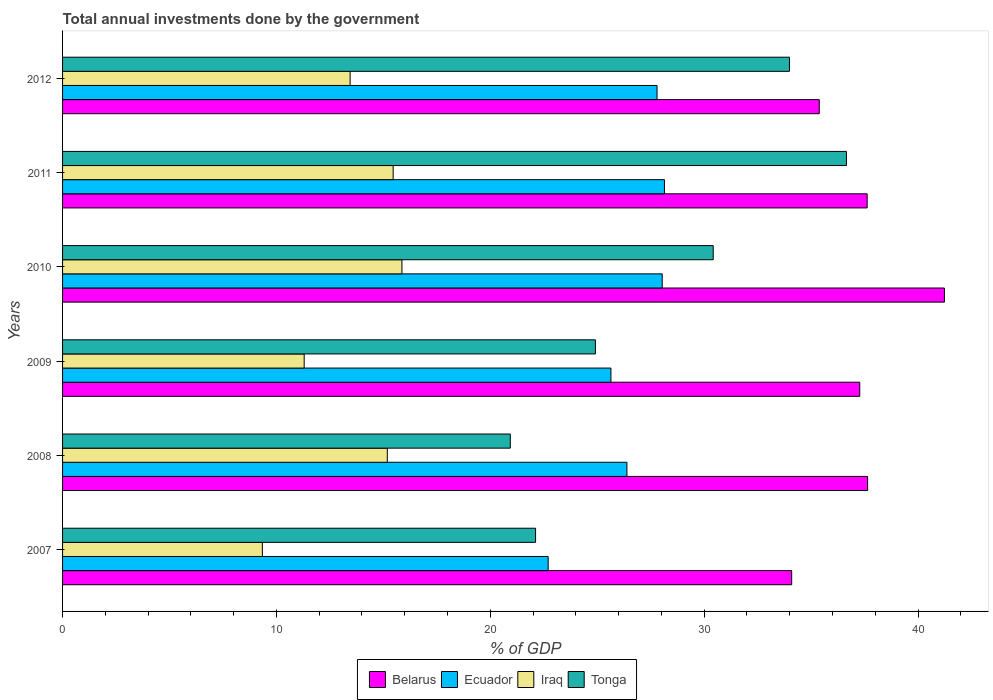How many bars are there on the 5th tick from the bottom?
Offer a very short reply. 4. What is the total annual investments done by the government in Belarus in 2012?
Provide a short and direct response. 35.38. Across all years, what is the maximum total annual investments done by the government in Tonga?
Offer a terse response. 36.65. Across all years, what is the minimum total annual investments done by the government in Ecuador?
Offer a terse response. 22.7. In which year was the total annual investments done by the government in Iraq maximum?
Your response must be concise. 2010. What is the total total annual investments done by the government in Belarus in the graph?
Give a very brief answer. 223.24. What is the difference between the total annual investments done by the government in Belarus in 2008 and that in 2009?
Your answer should be compact. 0.37. What is the difference between the total annual investments done by the government in Iraq in 2010 and the total annual investments done by the government in Ecuador in 2007?
Make the answer very short. -6.84. What is the average total annual investments done by the government in Ecuador per year?
Provide a short and direct response. 26.45. In the year 2008, what is the difference between the total annual investments done by the government in Belarus and total annual investments done by the government in Iraq?
Provide a short and direct response. 22.46. What is the ratio of the total annual investments done by the government in Ecuador in 2009 to that in 2010?
Your answer should be very brief. 0.91. Is the total annual investments done by the government in Ecuador in 2007 less than that in 2010?
Make the answer very short. Yes. What is the difference between the highest and the second highest total annual investments done by the government in Iraq?
Make the answer very short. 0.41. What is the difference between the highest and the lowest total annual investments done by the government in Tonga?
Make the answer very short. 15.72. What does the 2nd bar from the top in 2008 represents?
Make the answer very short. Iraq. What does the 1st bar from the bottom in 2008 represents?
Provide a succinct answer. Belarus. Is it the case that in every year, the sum of the total annual investments done by the government in Ecuador and total annual investments done by the government in Belarus is greater than the total annual investments done by the government in Iraq?
Keep it short and to the point. Yes. How many bars are there?
Ensure brevity in your answer.  24. Are all the bars in the graph horizontal?
Make the answer very short. Yes. How many years are there in the graph?
Provide a short and direct response. 6. Are the values on the major ticks of X-axis written in scientific E-notation?
Your answer should be compact. No. Does the graph contain any zero values?
Offer a very short reply. No. How many legend labels are there?
Offer a very short reply. 4. How are the legend labels stacked?
Ensure brevity in your answer.  Horizontal. What is the title of the graph?
Your answer should be very brief. Total annual investments done by the government. What is the label or title of the X-axis?
Give a very brief answer. % of GDP. What is the % of GDP in Belarus in 2007?
Make the answer very short. 34.09. What is the % of GDP in Ecuador in 2007?
Make the answer very short. 22.7. What is the % of GDP in Iraq in 2007?
Your answer should be very brief. 9.34. What is the % of GDP in Tonga in 2007?
Offer a very short reply. 22.12. What is the % of GDP in Belarus in 2008?
Keep it short and to the point. 37.64. What is the % of GDP of Ecuador in 2008?
Keep it short and to the point. 26.39. What is the % of GDP in Iraq in 2008?
Offer a very short reply. 15.18. What is the % of GDP of Tonga in 2008?
Offer a very short reply. 20.93. What is the % of GDP in Belarus in 2009?
Offer a very short reply. 37.27. What is the % of GDP in Ecuador in 2009?
Your answer should be very brief. 25.64. What is the % of GDP in Iraq in 2009?
Your response must be concise. 11.3. What is the % of GDP of Tonga in 2009?
Offer a very short reply. 24.91. What is the % of GDP in Belarus in 2010?
Your answer should be compact. 41.23. What is the % of GDP in Ecuador in 2010?
Make the answer very short. 28.04. What is the % of GDP of Iraq in 2010?
Your response must be concise. 15.87. What is the % of GDP in Tonga in 2010?
Your answer should be compact. 30.42. What is the % of GDP in Belarus in 2011?
Provide a succinct answer. 37.62. What is the % of GDP of Ecuador in 2011?
Your response must be concise. 28.14. What is the % of GDP in Iraq in 2011?
Offer a terse response. 15.46. What is the % of GDP in Tonga in 2011?
Offer a terse response. 36.65. What is the % of GDP in Belarus in 2012?
Your response must be concise. 35.38. What is the % of GDP in Ecuador in 2012?
Your answer should be very brief. 27.8. What is the % of GDP in Iraq in 2012?
Your answer should be compact. 13.45. What is the % of GDP of Tonga in 2012?
Your answer should be compact. 33.99. Across all years, what is the maximum % of GDP of Belarus?
Provide a short and direct response. 41.23. Across all years, what is the maximum % of GDP of Ecuador?
Offer a very short reply. 28.14. Across all years, what is the maximum % of GDP of Iraq?
Keep it short and to the point. 15.87. Across all years, what is the maximum % of GDP in Tonga?
Provide a short and direct response. 36.65. Across all years, what is the minimum % of GDP of Belarus?
Make the answer very short. 34.09. Across all years, what is the minimum % of GDP of Ecuador?
Your answer should be very brief. 22.7. Across all years, what is the minimum % of GDP in Iraq?
Provide a short and direct response. 9.34. Across all years, what is the minimum % of GDP of Tonga?
Offer a very short reply. 20.93. What is the total % of GDP of Belarus in the graph?
Make the answer very short. 223.24. What is the total % of GDP in Ecuador in the graph?
Your answer should be very brief. 158.71. What is the total % of GDP of Iraq in the graph?
Offer a terse response. 80.59. What is the total % of GDP of Tonga in the graph?
Ensure brevity in your answer.  169.03. What is the difference between the % of GDP in Belarus in 2007 and that in 2008?
Offer a very short reply. -3.55. What is the difference between the % of GDP of Ecuador in 2007 and that in 2008?
Provide a succinct answer. -3.68. What is the difference between the % of GDP in Iraq in 2007 and that in 2008?
Provide a succinct answer. -5.84. What is the difference between the % of GDP in Tonga in 2007 and that in 2008?
Keep it short and to the point. 1.18. What is the difference between the % of GDP in Belarus in 2007 and that in 2009?
Your answer should be compact. -3.18. What is the difference between the % of GDP of Ecuador in 2007 and that in 2009?
Give a very brief answer. -2.93. What is the difference between the % of GDP in Iraq in 2007 and that in 2009?
Provide a short and direct response. -1.95. What is the difference between the % of GDP in Tonga in 2007 and that in 2009?
Your answer should be very brief. -2.8. What is the difference between the % of GDP in Belarus in 2007 and that in 2010?
Keep it short and to the point. -7.14. What is the difference between the % of GDP in Ecuador in 2007 and that in 2010?
Keep it short and to the point. -5.33. What is the difference between the % of GDP in Iraq in 2007 and that in 2010?
Your response must be concise. -6.53. What is the difference between the % of GDP in Tonga in 2007 and that in 2010?
Provide a succinct answer. -8.31. What is the difference between the % of GDP in Belarus in 2007 and that in 2011?
Your answer should be very brief. -3.53. What is the difference between the % of GDP in Ecuador in 2007 and that in 2011?
Make the answer very short. -5.44. What is the difference between the % of GDP of Iraq in 2007 and that in 2011?
Keep it short and to the point. -6.12. What is the difference between the % of GDP in Tonga in 2007 and that in 2011?
Keep it short and to the point. -14.53. What is the difference between the % of GDP of Belarus in 2007 and that in 2012?
Give a very brief answer. -1.29. What is the difference between the % of GDP of Ecuador in 2007 and that in 2012?
Give a very brief answer. -5.09. What is the difference between the % of GDP of Iraq in 2007 and that in 2012?
Offer a terse response. -4.1. What is the difference between the % of GDP of Tonga in 2007 and that in 2012?
Offer a terse response. -11.87. What is the difference between the % of GDP in Belarus in 2008 and that in 2009?
Provide a succinct answer. 0.37. What is the difference between the % of GDP in Ecuador in 2008 and that in 2009?
Your answer should be very brief. 0.75. What is the difference between the % of GDP in Iraq in 2008 and that in 2009?
Provide a succinct answer. 3.89. What is the difference between the % of GDP of Tonga in 2008 and that in 2009?
Keep it short and to the point. -3.98. What is the difference between the % of GDP of Belarus in 2008 and that in 2010?
Your answer should be very brief. -3.59. What is the difference between the % of GDP in Ecuador in 2008 and that in 2010?
Ensure brevity in your answer.  -1.65. What is the difference between the % of GDP in Iraq in 2008 and that in 2010?
Your response must be concise. -0.68. What is the difference between the % of GDP of Tonga in 2008 and that in 2010?
Your response must be concise. -9.49. What is the difference between the % of GDP of Belarus in 2008 and that in 2011?
Keep it short and to the point. 0.02. What is the difference between the % of GDP in Ecuador in 2008 and that in 2011?
Offer a very short reply. -1.75. What is the difference between the % of GDP in Iraq in 2008 and that in 2011?
Your answer should be very brief. -0.27. What is the difference between the % of GDP of Tonga in 2008 and that in 2011?
Your answer should be compact. -15.72. What is the difference between the % of GDP in Belarus in 2008 and that in 2012?
Keep it short and to the point. 2.26. What is the difference between the % of GDP of Ecuador in 2008 and that in 2012?
Your answer should be compact. -1.41. What is the difference between the % of GDP in Iraq in 2008 and that in 2012?
Offer a terse response. 1.74. What is the difference between the % of GDP of Tonga in 2008 and that in 2012?
Provide a succinct answer. -13.05. What is the difference between the % of GDP of Belarus in 2009 and that in 2010?
Your answer should be very brief. -3.96. What is the difference between the % of GDP of Ecuador in 2009 and that in 2010?
Your response must be concise. -2.4. What is the difference between the % of GDP in Iraq in 2009 and that in 2010?
Your answer should be compact. -4.57. What is the difference between the % of GDP of Tonga in 2009 and that in 2010?
Offer a very short reply. -5.51. What is the difference between the % of GDP of Belarus in 2009 and that in 2011?
Keep it short and to the point. -0.35. What is the difference between the % of GDP of Ecuador in 2009 and that in 2011?
Provide a short and direct response. -2.5. What is the difference between the % of GDP of Iraq in 2009 and that in 2011?
Provide a short and direct response. -4.16. What is the difference between the % of GDP in Tonga in 2009 and that in 2011?
Offer a very short reply. -11.74. What is the difference between the % of GDP in Belarus in 2009 and that in 2012?
Provide a short and direct response. 1.89. What is the difference between the % of GDP in Ecuador in 2009 and that in 2012?
Offer a very short reply. -2.16. What is the difference between the % of GDP of Iraq in 2009 and that in 2012?
Your response must be concise. -2.15. What is the difference between the % of GDP of Tonga in 2009 and that in 2012?
Provide a short and direct response. -9.07. What is the difference between the % of GDP of Belarus in 2010 and that in 2011?
Make the answer very short. 3.61. What is the difference between the % of GDP in Ecuador in 2010 and that in 2011?
Your response must be concise. -0.11. What is the difference between the % of GDP in Iraq in 2010 and that in 2011?
Offer a terse response. 0.41. What is the difference between the % of GDP in Tonga in 2010 and that in 2011?
Keep it short and to the point. -6.23. What is the difference between the % of GDP of Belarus in 2010 and that in 2012?
Offer a very short reply. 5.85. What is the difference between the % of GDP of Ecuador in 2010 and that in 2012?
Provide a succinct answer. 0.24. What is the difference between the % of GDP in Iraq in 2010 and that in 2012?
Offer a very short reply. 2.42. What is the difference between the % of GDP in Tonga in 2010 and that in 2012?
Offer a very short reply. -3.56. What is the difference between the % of GDP in Belarus in 2011 and that in 2012?
Offer a terse response. 2.24. What is the difference between the % of GDP of Ecuador in 2011 and that in 2012?
Keep it short and to the point. 0.35. What is the difference between the % of GDP in Iraq in 2011 and that in 2012?
Give a very brief answer. 2.01. What is the difference between the % of GDP of Tonga in 2011 and that in 2012?
Offer a terse response. 2.66. What is the difference between the % of GDP in Belarus in 2007 and the % of GDP in Ecuador in 2008?
Ensure brevity in your answer.  7.7. What is the difference between the % of GDP of Belarus in 2007 and the % of GDP of Iraq in 2008?
Your answer should be compact. 18.91. What is the difference between the % of GDP in Belarus in 2007 and the % of GDP in Tonga in 2008?
Offer a terse response. 13.16. What is the difference between the % of GDP of Ecuador in 2007 and the % of GDP of Iraq in 2008?
Provide a succinct answer. 7.52. What is the difference between the % of GDP of Ecuador in 2007 and the % of GDP of Tonga in 2008?
Keep it short and to the point. 1.77. What is the difference between the % of GDP of Iraq in 2007 and the % of GDP of Tonga in 2008?
Provide a succinct answer. -11.59. What is the difference between the % of GDP of Belarus in 2007 and the % of GDP of Ecuador in 2009?
Your response must be concise. 8.45. What is the difference between the % of GDP in Belarus in 2007 and the % of GDP in Iraq in 2009?
Give a very brief answer. 22.8. What is the difference between the % of GDP in Belarus in 2007 and the % of GDP in Tonga in 2009?
Ensure brevity in your answer.  9.18. What is the difference between the % of GDP of Ecuador in 2007 and the % of GDP of Iraq in 2009?
Your answer should be very brief. 11.41. What is the difference between the % of GDP of Ecuador in 2007 and the % of GDP of Tonga in 2009?
Ensure brevity in your answer.  -2.21. What is the difference between the % of GDP in Iraq in 2007 and the % of GDP in Tonga in 2009?
Your response must be concise. -15.57. What is the difference between the % of GDP in Belarus in 2007 and the % of GDP in Ecuador in 2010?
Keep it short and to the point. 6.05. What is the difference between the % of GDP of Belarus in 2007 and the % of GDP of Iraq in 2010?
Your response must be concise. 18.22. What is the difference between the % of GDP of Belarus in 2007 and the % of GDP of Tonga in 2010?
Ensure brevity in your answer.  3.67. What is the difference between the % of GDP in Ecuador in 2007 and the % of GDP in Iraq in 2010?
Provide a short and direct response. 6.84. What is the difference between the % of GDP of Ecuador in 2007 and the % of GDP of Tonga in 2010?
Provide a succinct answer. -7.72. What is the difference between the % of GDP in Iraq in 2007 and the % of GDP in Tonga in 2010?
Your response must be concise. -21.08. What is the difference between the % of GDP in Belarus in 2007 and the % of GDP in Ecuador in 2011?
Make the answer very short. 5.95. What is the difference between the % of GDP of Belarus in 2007 and the % of GDP of Iraq in 2011?
Make the answer very short. 18.63. What is the difference between the % of GDP of Belarus in 2007 and the % of GDP of Tonga in 2011?
Your answer should be compact. -2.56. What is the difference between the % of GDP in Ecuador in 2007 and the % of GDP in Iraq in 2011?
Your response must be concise. 7.25. What is the difference between the % of GDP in Ecuador in 2007 and the % of GDP in Tonga in 2011?
Make the answer very short. -13.95. What is the difference between the % of GDP of Iraq in 2007 and the % of GDP of Tonga in 2011?
Offer a very short reply. -27.31. What is the difference between the % of GDP of Belarus in 2007 and the % of GDP of Ecuador in 2012?
Your answer should be compact. 6.3. What is the difference between the % of GDP in Belarus in 2007 and the % of GDP in Iraq in 2012?
Your answer should be compact. 20.65. What is the difference between the % of GDP of Belarus in 2007 and the % of GDP of Tonga in 2012?
Offer a terse response. 0.1. What is the difference between the % of GDP of Ecuador in 2007 and the % of GDP of Iraq in 2012?
Your response must be concise. 9.26. What is the difference between the % of GDP in Ecuador in 2007 and the % of GDP in Tonga in 2012?
Your answer should be compact. -11.28. What is the difference between the % of GDP of Iraq in 2007 and the % of GDP of Tonga in 2012?
Offer a terse response. -24.65. What is the difference between the % of GDP of Belarus in 2008 and the % of GDP of Ecuador in 2009?
Provide a short and direct response. 12. What is the difference between the % of GDP of Belarus in 2008 and the % of GDP of Iraq in 2009?
Your answer should be compact. 26.34. What is the difference between the % of GDP in Belarus in 2008 and the % of GDP in Tonga in 2009?
Give a very brief answer. 12.73. What is the difference between the % of GDP of Ecuador in 2008 and the % of GDP of Iraq in 2009?
Provide a short and direct response. 15.09. What is the difference between the % of GDP of Ecuador in 2008 and the % of GDP of Tonga in 2009?
Offer a terse response. 1.47. What is the difference between the % of GDP in Iraq in 2008 and the % of GDP in Tonga in 2009?
Your answer should be compact. -9.73. What is the difference between the % of GDP in Belarus in 2008 and the % of GDP in Ecuador in 2010?
Offer a terse response. 9.6. What is the difference between the % of GDP of Belarus in 2008 and the % of GDP of Iraq in 2010?
Offer a very short reply. 21.77. What is the difference between the % of GDP of Belarus in 2008 and the % of GDP of Tonga in 2010?
Ensure brevity in your answer.  7.22. What is the difference between the % of GDP of Ecuador in 2008 and the % of GDP of Iraq in 2010?
Your response must be concise. 10.52. What is the difference between the % of GDP in Ecuador in 2008 and the % of GDP in Tonga in 2010?
Offer a terse response. -4.04. What is the difference between the % of GDP in Iraq in 2008 and the % of GDP in Tonga in 2010?
Your answer should be compact. -15.24. What is the difference between the % of GDP in Belarus in 2008 and the % of GDP in Ecuador in 2011?
Offer a terse response. 9.5. What is the difference between the % of GDP of Belarus in 2008 and the % of GDP of Iraq in 2011?
Keep it short and to the point. 22.18. What is the difference between the % of GDP in Ecuador in 2008 and the % of GDP in Iraq in 2011?
Your answer should be very brief. 10.93. What is the difference between the % of GDP in Ecuador in 2008 and the % of GDP in Tonga in 2011?
Give a very brief answer. -10.26. What is the difference between the % of GDP in Iraq in 2008 and the % of GDP in Tonga in 2011?
Ensure brevity in your answer.  -21.47. What is the difference between the % of GDP in Belarus in 2008 and the % of GDP in Ecuador in 2012?
Your answer should be very brief. 9.85. What is the difference between the % of GDP of Belarus in 2008 and the % of GDP of Iraq in 2012?
Keep it short and to the point. 24.2. What is the difference between the % of GDP of Belarus in 2008 and the % of GDP of Tonga in 2012?
Make the answer very short. 3.65. What is the difference between the % of GDP of Ecuador in 2008 and the % of GDP of Iraq in 2012?
Give a very brief answer. 12.94. What is the difference between the % of GDP of Ecuador in 2008 and the % of GDP of Tonga in 2012?
Your answer should be very brief. -7.6. What is the difference between the % of GDP of Iraq in 2008 and the % of GDP of Tonga in 2012?
Provide a succinct answer. -18.8. What is the difference between the % of GDP in Belarus in 2009 and the % of GDP in Ecuador in 2010?
Offer a very short reply. 9.24. What is the difference between the % of GDP in Belarus in 2009 and the % of GDP in Iraq in 2010?
Provide a succinct answer. 21.41. What is the difference between the % of GDP in Belarus in 2009 and the % of GDP in Tonga in 2010?
Ensure brevity in your answer.  6.85. What is the difference between the % of GDP in Ecuador in 2009 and the % of GDP in Iraq in 2010?
Your answer should be compact. 9.77. What is the difference between the % of GDP of Ecuador in 2009 and the % of GDP of Tonga in 2010?
Give a very brief answer. -4.78. What is the difference between the % of GDP of Iraq in 2009 and the % of GDP of Tonga in 2010?
Give a very brief answer. -19.13. What is the difference between the % of GDP of Belarus in 2009 and the % of GDP of Ecuador in 2011?
Your answer should be very brief. 9.13. What is the difference between the % of GDP of Belarus in 2009 and the % of GDP of Iraq in 2011?
Your answer should be compact. 21.82. What is the difference between the % of GDP of Belarus in 2009 and the % of GDP of Tonga in 2011?
Ensure brevity in your answer.  0.62. What is the difference between the % of GDP in Ecuador in 2009 and the % of GDP in Iraq in 2011?
Provide a short and direct response. 10.18. What is the difference between the % of GDP of Ecuador in 2009 and the % of GDP of Tonga in 2011?
Your answer should be compact. -11.01. What is the difference between the % of GDP of Iraq in 2009 and the % of GDP of Tonga in 2011?
Keep it short and to the point. -25.36. What is the difference between the % of GDP in Belarus in 2009 and the % of GDP in Ecuador in 2012?
Offer a terse response. 9.48. What is the difference between the % of GDP of Belarus in 2009 and the % of GDP of Iraq in 2012?
Offer a very short reply. 23.83. What is the difference between the % of GDP of Belarus in 2009 and the % of GDP of Tonga in 2012?
Your answer should be very brief. 3.29. What is the difference between the % of GDP of Ecuador in 2009 and the % of GDP of Iraq in 2012?
Your response must be concise. 12.19. What is the difference between the % of GDP of Ecuador in 2009 and the % of GDP of Tonga in 2012?
Give a very brief answer. -8.35. What is the difference between the % of GDP in Iraq in 2009 and the % of GDP in Tonga in 2012?
Your response must be concise. -22.69. What is the difference between the % of GDP in Belarus in 2010 and the % of GDP in Ecuador in 2011?
Your answer should be very brief. 13.09. What is the difference between the % of GDP in Belarus in 2010 and the % of GDP in Iraq in 2011?
Offer a very short reply. 25.77. What is the difference between the % of GDP in Belarus in 2010 and the % of GDP in Tonga in 2011?
Offer a very short reply. 4.58. What is the difference between the % of GDP in Ecuador in 2010 and the % of GDP in Iraq in 2011?
Make the answer very short. 12.58. What is the difference between the % of GDP of Ecuador in 2010 and the % of GDP of Tonga in 2011?
Offer a very short reply. -8.61. What is the difference between the % of GDP of Iraq in 2010 and the % of GDP of Tonga in 2011?
Keep it short and to the point. -20.78. What is the difference between the % of GDP in Belarus in 2010 and the % of GDP in Ecuador in 2012?
Your response must be concise. 13.44. What is the difference between the % of GDP of Belarus in 2010 and the % of GDP of Iraq in 2012?
Provide a short and direct response. 27.79. What is the difference between the % of GDP in Belarus in 2010 and the % of GDP in Tonga in 2012?
Offer a very short reply. 7.24. What is the difference between the % of GDP in Ecuador in 2010 and the % of GDP in Iraq in 2012?
Give a very brief answer. 14.59. What is the difference between the % of GDP in Ecuador in 2010 and the % of GDP in Tonga in 2012?
Provide a short and direct response. -5.95. What is the difference between the % of GDP in Iraq in 2010 and the % of GDP in Tonga in 2012?
Offer a terse response. -18.12. What is the difference between the % of GDP in Belarus in 2011 and the % of GDP in Ecuador in 2012?
Offer a terse response. 9.82. What is the difference between the % of GDP in Belarus in 2011 and the % of GDP in Iraq in 2012?
Ensure brevity in your answer.  24.17. What is the difference between the % of GDP of Belarus in 2011 and the % of GDP of Tonga in 2012?
Offer a very short reply. 3.63. What is the difference between the % of GDP of Ecuador in 2011 and the % of GDP of Iraq in 2012?
Provide a short and direct response. 14.7. What is the difference between the % of GDP in Ecuador in 2011 and the % of GDP in Tonga in 2012?
Provide a short and direct response. -5.85. What is the difference between the % of GDP in Iraq in 2011 and the % of GDP in Tonga in 2012?
Make the answer very short. -18.53. What is the average % of GDP of Belarus per year?
Give a very brief answer. 37.21. What is the average % of GDP in Ecuador per year?
Provide a short and direct response. 26.45. What is the average % of GDP in Iraq per year?
Provide a short and direct response. 13.43. What is the average % of GDP in Tonga per year?
Provide a short and direct response. 28.17. In the year 2007, what is the difference between the % of GDP of Belarus and % of GDP of Ecuador?
Make the answer very short. 11.39. In the year 2007, what is the difference between the % of GDP in Belarus and % of GDP in Iraq?
Ensure brevity in your answer.  24.75. In the year 2007, what is the difference between the % of GDP in Belarus and % of GDP in Tonga?
Provide a short and direct response. 11.97. In the year 2007, what is the difference between the % of GDP in Ecuador and % of GDP in Iraq?
Offer a very short reply. 13.36. In the year 2007, what is the difference between the % of GDP in Ecuador and % of GDP in Tonga?
Your response must be concise. 0.59. In the year 2007, what is the difference between the % of GDP in Iraq and % of GDP in Tonga?
Offer a terse response. -12.78. In the year 2008, what is the difference between the % of GDP of Belarus and % of GDP of Ecuador?
Ensure brevity in your answer.  11.25. In the year 2008, what is the difference between the % of GDP in Belarus and % of GDP in Iraq?
Your answer should be compact. 22.46. In the year 2008, what is the difference between the % of GDP of Belarus and % of GDP of Tonga?
Keep it short and to the point. 16.71. In the year 2008, what is the difference between the % of GDP of Ecuador and % of GDP of Iraq?
Your answer should be compact. 11.2. In the year 2008, what is the difference between the % of GDP of Ecuador and % of GDP of Tonga?
Your response must be concise. 5.45. In the year 2008, what is the difference between the % of GDP of Iraq and % of GDP of Tonga?
Offer a very short reply. -5.75. In the year 2009, what is the difference between the % of GDP in Belarus and % of GDP in Ecuador?
Your answer should be compact. 11.63. In the year 2009, what is the difference between the % of GDP of Belarus and % of GDP of Iraq?
Provide a short and direct response. 25.98. In the year 2009, what is the difference between the % of GDP in Belarus and % of GDP in Tonga?
Provide a succinct answer. 12.36. In the year 2009, what is the difference between the % of GDP in Ecuador and % of GDP in Iraq?
Your response must be concise. 14.34. In the year 2009, what is the difference between the % of GDP in Ecuador and % of GDP in Tonga?
Offer a very short reply. 0.73. In the year 2009, what is the difference between the % of GDP of Iraq and % of GDP of Tonga?
Ensure brevity in your answer.  -13.62. In the year 2010, what is the difference between the % of GDP in Belarus and % of GDP in Ecuador?
Your answer should be very brief. 13.19. In the year 2010, what is the difference between the % of GDP of Belarus and % of GDP of Iraq?
Offer a very short reply. 25.36. In the year 2010, what is the difference between the % of GDP of Belarus and % of GDP of Tonga?
Keep it short and to the point. 10.81. In the year 2010, what is the difference between the % of GDP in Ecuador and % of GDP in Iraq?
Your response must be concise. 12.17. In the year 2010, what is the difference between the % of GDP of Ecuador and % of GDP of Tonga?
Keep it short and to the point. -2.39. In the year 2010, what is the difference between the % of GDP of Iraq and % of GDP of Tonga?
Offer a terse response. -14.55. In the year 2011, what is the difference between the % of GDP in Belarus and % of GDP in Ecuador?
Make the answer very short. 9.48. In the year 2011, what is the difference between the % of GDP in Belarus and % of GDP in Iraq?
Offer a terse response. 22.16. In the year 2011, what is the difference between the % of GDP of Belarus and % of GDP of Tonga?
Keep it short and to the point. 0.97. In the year 2011, what is the difference between the % of GDP in Ecuador and % of GDP in Iraq?
Offer a terse response. 12.68. In the year 2011, what is the difference between the % of GDP of Ecuador and % of GDP of Tonga?
Ensure brevity in your answer.  -8.51. In the year 2011, what is the difference between the % of GDP in Iraq and % of GDP in Tonga?
Give a very brief answer. -21.19. In the year 2012, what is the difference between the % of GDP in Belarus and % of GDP in Ecuador?
Your answer should be very brief. 7.58. In the year 2012, what is the difference between the % of GDP in Belarus and % of GDP in Iraq?
Provide a succinct answer. 21.94. In the year 2012, what is the difference between the % of GDP in Belarus and % of GDP in Tonga?
Give a very brief answer. 1.39. In the year 2012, what is the difference between the % of GDP in Ecuador and % of GDP in Iraq?
Your answer should be compact. 14.35. In the year 2012, what is the difference between the % of GDP of Ecuador and % of GDP of Tonga?
Provide a succinct answer. -6.19. In the year 2012, what is the difference between the % of GDP in Iraq and % of GDP in Tonga?
Offer a very short reply. -20.54. What is the ratio of the % of GDP of Belarus in 2007 to that in 2008?
Give a very brief answer. 0.91. What is the ratio of the % of GDP in Ecuador in 2007 to that in 2008?
Provide a short and direct response. 0.86. What is the ratio of the % of GDP in Iraq in 2007 to that in 2008?
Give a very brief answer. 0.62. What is the ratio of the % of GDP in Tonga in 2007 to that in 2008?
Ensure brevity in your answer.  1.06. What is the ratio of the % of GDP in Belarus in 2007 to that in 2009?
Provide a succinct answer. 0.91. What is the ratio of the % of GDP of Ecuador in 2007 to that in 2009?
Your answer should be compact. 0.89. What is the ratio of the % of GDP of Iraq in 2007 to that in 2009?
Offer a terse response. 0.83. What is the ratio of the % of GDP in Tonga in 2007 to that in 2009?
Offer a very short reply. 0.89. What is the ratio of the % of GDP of Belarus in 2007 to that in 2010?
Make the answer very short. 0.83. What is the ratio of the % of GDP in Ecuador in 2007 to that in 2010?
Make the answer very short. 0.81. What is the ratio of the % of GDP in Iraq in 2007 to that in 2010?
Your answer should be very brief. 0.59. What is the ratio of the % of GDP of Tonga in 2007 to that in 2010?
Your response must be concise. 0.73. What is the ratio of the % of GDP of Belarus in 2007 to that in 2011?
Offer a very short reply. 0.91. What is the ratio of the % of GDP in Ecuador in 2007 to that in 2011?
Provide a short and direct response. 0.81. What is the ratio of the % of GDP in Iraq in 2007 to that in 2011?
Provide a succinct answer. 0.6. What is the ratio of the % of GDP of Tonga in 2007 to that in 2011?
Provide a short and direct response. 0.6. What is the ratio of the % of GDP of Belarus in 2007 to that in 2012?
Ensure brevity in your answer.  0.96. What is the ratio of the % of GDP of Ecuador in 2007 to that in 2012?
Offer a very short reply. 0.82. What is the ratio of the % of GDP in Iraq in 2007 to that in 2012?
Your answer should be compact. 0.69. What is the ratio of the % of GDP in Tonga in 2007 to that in 2012?
Ensure brevity in your answer.  0.65. What is the ratio of the % of GDP of Belarus in 2008 to that in 2009?
Ensure brevity in your answer.  1.01. What is the ratio of the % of GDP in Ecuador in 2008 to that in 2009?
Provide a succinct answer. 1.03. What is the ratio of the % of GDP in Iraq in 2008 to that in 2009?
Your response must be concise. 1.34. What is the ratio of the % of GDP in Tonga in 2008 to that in 2009?
Give a very brief answer. 0.84. What is the ratio of the % of GDP of Belarus in 2008 to that in 2010?
Make the answer very short. 0.91. What is the ratio of the % of GDP of Ecuador in 2008 to that in 2010?
Provide a short and direct response. 0.94. What is the ratio of the % of GDP in Iraq in 2008 to that in 2010?
Give a very brief answer. 0.96. What is the ratio of the % of GDP in Tonga in 2008 to that in 2010?
Provide a succinct answer. 0.69. What is the ratio of the % of GDP of Ecuador in 2008 to that in 2011?
Offer a very short reply. 0.94. What is the ratio of the % of GDP in Iraq in 2008 to that in 2011?
Provide a short and direct response. 0.98. What is the ratio of the % of GDP in Tonga in 2008 to that in 2011?
Your response must be concise. 0.57. What is the ratio of the % of GDP in Belarus in 2008 to that in 2012?
Keep it short and to the point. 1.06. What is the ratio of the % of GDP of Ecuador in 2008 to that in 2012?
Your answer should be very brief. 0.95. What is the ratio of the % of GDP in Iraq in 2008 to that in 2012?
Ensure brevity in your answer.  1.13. What is the ratio of the % of GDP in Tonga in 2008 to that in 2012?
Offer a terse response. 0.62. What is the ratio of the % of GDP of Belarus in 2009 to that in 2010?
Offer a very short reply. 0.9. What is the ratio of the % of GDP of Ecuador in 2009 to that in 2010?
Give a very brief answer. 0.91. What is the ratio of the % of GDP of Iraq in 2009 to that in 2010?
Your answer should be very brief. 0.71. What is the ratio of the % of GDP in Tonga in 2009 to that in 2010?
Your answer should be very brief. 0.82. What is the ratio of the % of GDP in Ecuador in 2009 to that in 2011?
Keep it short and to the point. 0.91. What is the ratio of the % of GDP of Iraq in 2009 to that in 2011?
Offer a terse response. 0.73. What is the ratio of the % of GDP of Tonga in 2009 to that in 2011?
Your answer should be compact. 0.68. What is the ratio of the % of GDP of Belarus in 2009 to that in 2012?
Keep it short and to the point. 1.05. What is the ratio of the % of GDP of Ecuador in 2009 to that in 2012?
Your response must be concise. 0.92. What is the ratio of the % of GDP in Iraq in 2009 to that in 2012?
Provide a succinct answer. 0.84. What is the ratio of the % of GDP in Tonga in 2009 to that in 2012?
Provide a short and direct response. 0.73. What is the ratio of the % of GDP of Belarus in 2010 to that in 2011?
Your answer should be compact. 1.1. What is the ratio of the % of GDP of Ecuador in 2010 to that in 2011?
Provide a succinct answer. 1. What is the ratio of the % of GDP in Iraq in 2010 to that in 2011?
Give a very brief answer. 1.03. What is the ratio of the % of GDP of Tonga in 2010 to that in 2011?
Your response must be concise. 0.83. What is the ratio of the % of GDP in Belarus in 2010 to that in 2012?
Provide a succinct answer. 1.17. What is the ratio of the % of GDP in Ecuador in 2010 to that in 2012?
Your answer should be compact. 1.01. What is the ratio of the % of GDP of Iraq in 2010 to that in 2012?
Ensure brevity in your answer.  1.18. What is the ratio of the % of GDP of Tonga in 2010 to that in 2012?
Your answer should be very brief. 0.9. What is the ratio of the % of GDP in Belarus in 2011 to that in 2012?
Provide a succinct answer. 1.06. What is the ratio of the % of GDP of Ecuador in 2011 to that in 2012?
Your response must be concise. 1.01. What is the ratio of the % of GDP of Iraq in 2011 to that in 2012?
Ensure brevity in your answer.  1.15. What is the ratio of the % of GDP of Tonga in 2011 to that in 2012?
Your answer should be very brief. 1.08. What is the difference between the highest and the second highest % of GDP in Belarus?
Make the answer very short. 3.59. What is the difference between the highest and the second highest % of GDP of Ecuador?
Give a very brief answer. 0.11. What is the difference between the highest and the second highest % of GDP of Iraq?
Your answer should be compact. 0.41. What is the difference between the highest and the second highest % of GDP in Tonga?
Offer a terse response. 2.66. What is the difference between the highest and the lowest % of GDP of Belarus?
Give a very brief answer. 7.14. What is the difference between the highest and the lowest % of GDP in Ecuador?
Provide a short and direct response. 5.44. What is the difference between the highest and the lowest % of GDP of Iraq?
Your answer should be compact. 6.53. What is the difference between the highest and the lowest % of GDP in Tonga?
Provide a succinct answer. 15.72. 